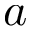Convert formula to latex. <formula><loc_0><loc_0><loc_500><loc_500>a</formula> 